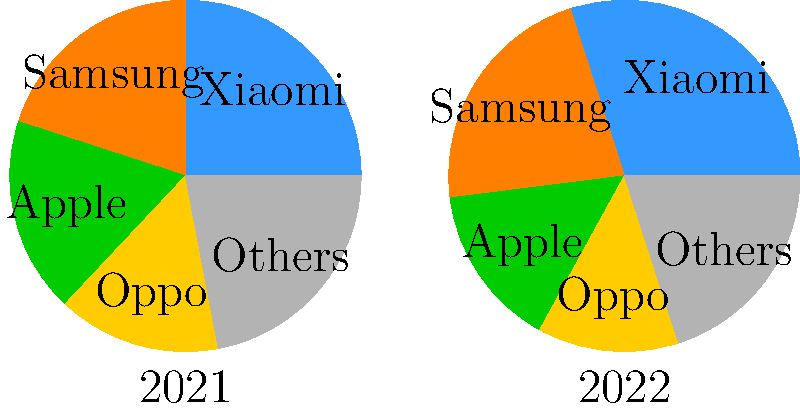Based on the pie charts showing smartphone market share in Europe for 2021 and 2022, what is the percentage increase in Xiaomi's market share from 2021 to 2022? To calculate the percentage increase in Xiaomi's market share from 2021 to 2022, we need to follow these steps:

1. Identify Xiaomi's market share in 2021 and 2022:
   2021: 25%
   2022: 30%

2. Calculate the absolute increase:
   $30\% - 25\% = 5\%$

3. Calculate the percentage increase:
   Percentage increase = $\frac{\text{Increase}}{\text{Original Value}} \times 100\%$
   
   $= \frac{5\%}{25\%} \times 100\%$
   
   $= 0.2 \times 100\%$
   
   $= 20\%$

Therefore, Xiaomi's market share increased by 20% from 2021 to 2022.
Answer: 20% 